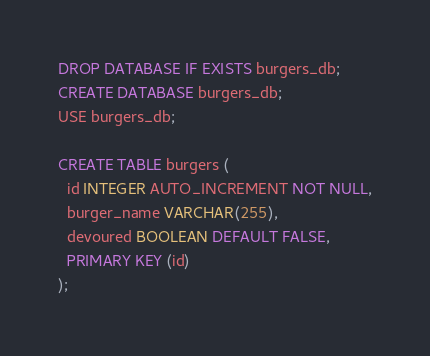<code> <loc_0><loc_0><loc_500><loc_500><_SQL_>DROP DATABASE IF EXISTS burgers_db;
CREATE DATABASE burgers_db;
USE burgers_db;

CREATE TABLE burgers (
  id INTEGER AUTO_INCREMENT NOT NULL,
  burger_name VARCHAR(255),
  devoured BOOLEAN DEFAULT FALSE,
  PRIMARY KEY (id)
);</code> 